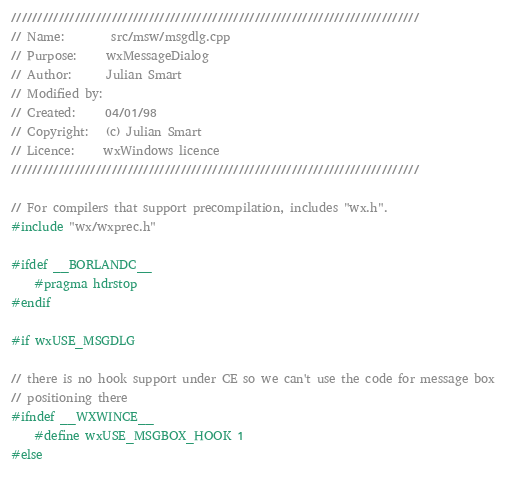Convert code to text. <code><loc_0><loc_0><loc_500><loc_500><_C++_>/////////////////////////////////////////////////////////////////////////////
// Name:        src/msw/msgdlg.cpp
// Purpose:     wxMessageDialog
// Author:      Julian Smart
// Modified by:
// Created:     04/01/98
// Copyright:   (c) Julian Smart
// Licence:     wxWindows licence
/////////////////////////////////////////////////////////////////////////////

// For compilers that support precompilation, includes "wx.h".
#include "wx/wxprec.h"

#ifdef __BORLANDC__
    #pragma hdrstop
#endif

#if wxUSE_MSGDLG

// there is no hook support under CE so we can't use the code for message box
// positioning there
#ifndef __WXWINCE__
    #define wxUSE_MSGBOX_HOOK 1
#else</code> 